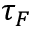Convert formula to latex. <formula><loc_0><loc_0><loc_500><loc_500>\tau _ { F }</formula> 